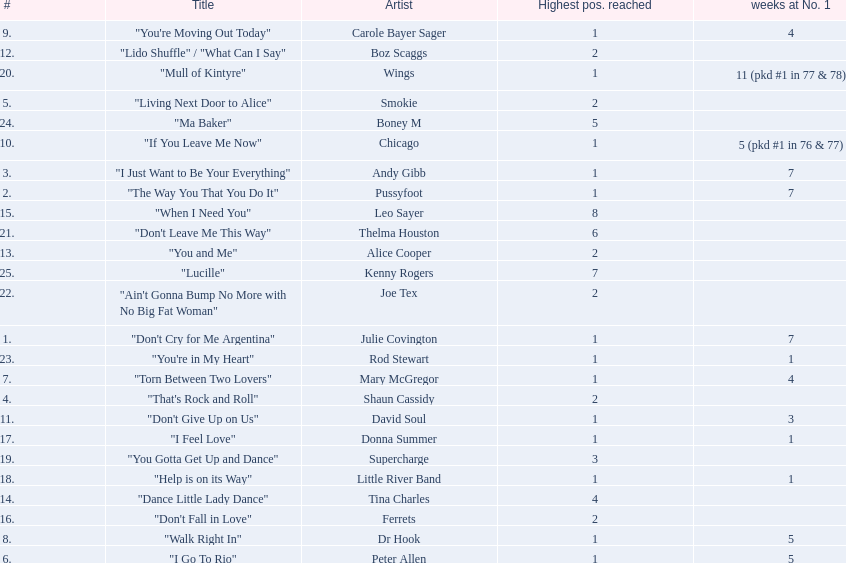Who had the one of the least weeks at number one? Rod Stewart. Who had no week at number one? Shaun Cassidy. Who had the highest number of weeks at number one? Wings. 